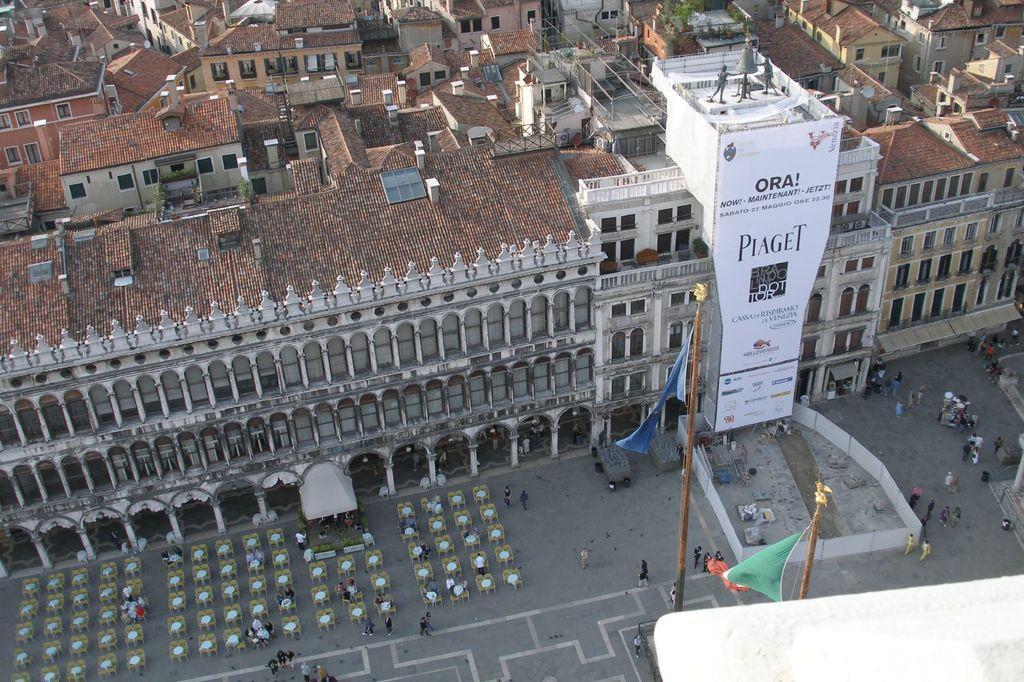How would you summarize this image in a sentence or two? In the picture there is a road, on the road there may be many tables and chairs, there are people walking on the road, there are houses, there are poles with the flags, there is a banner with the text. 